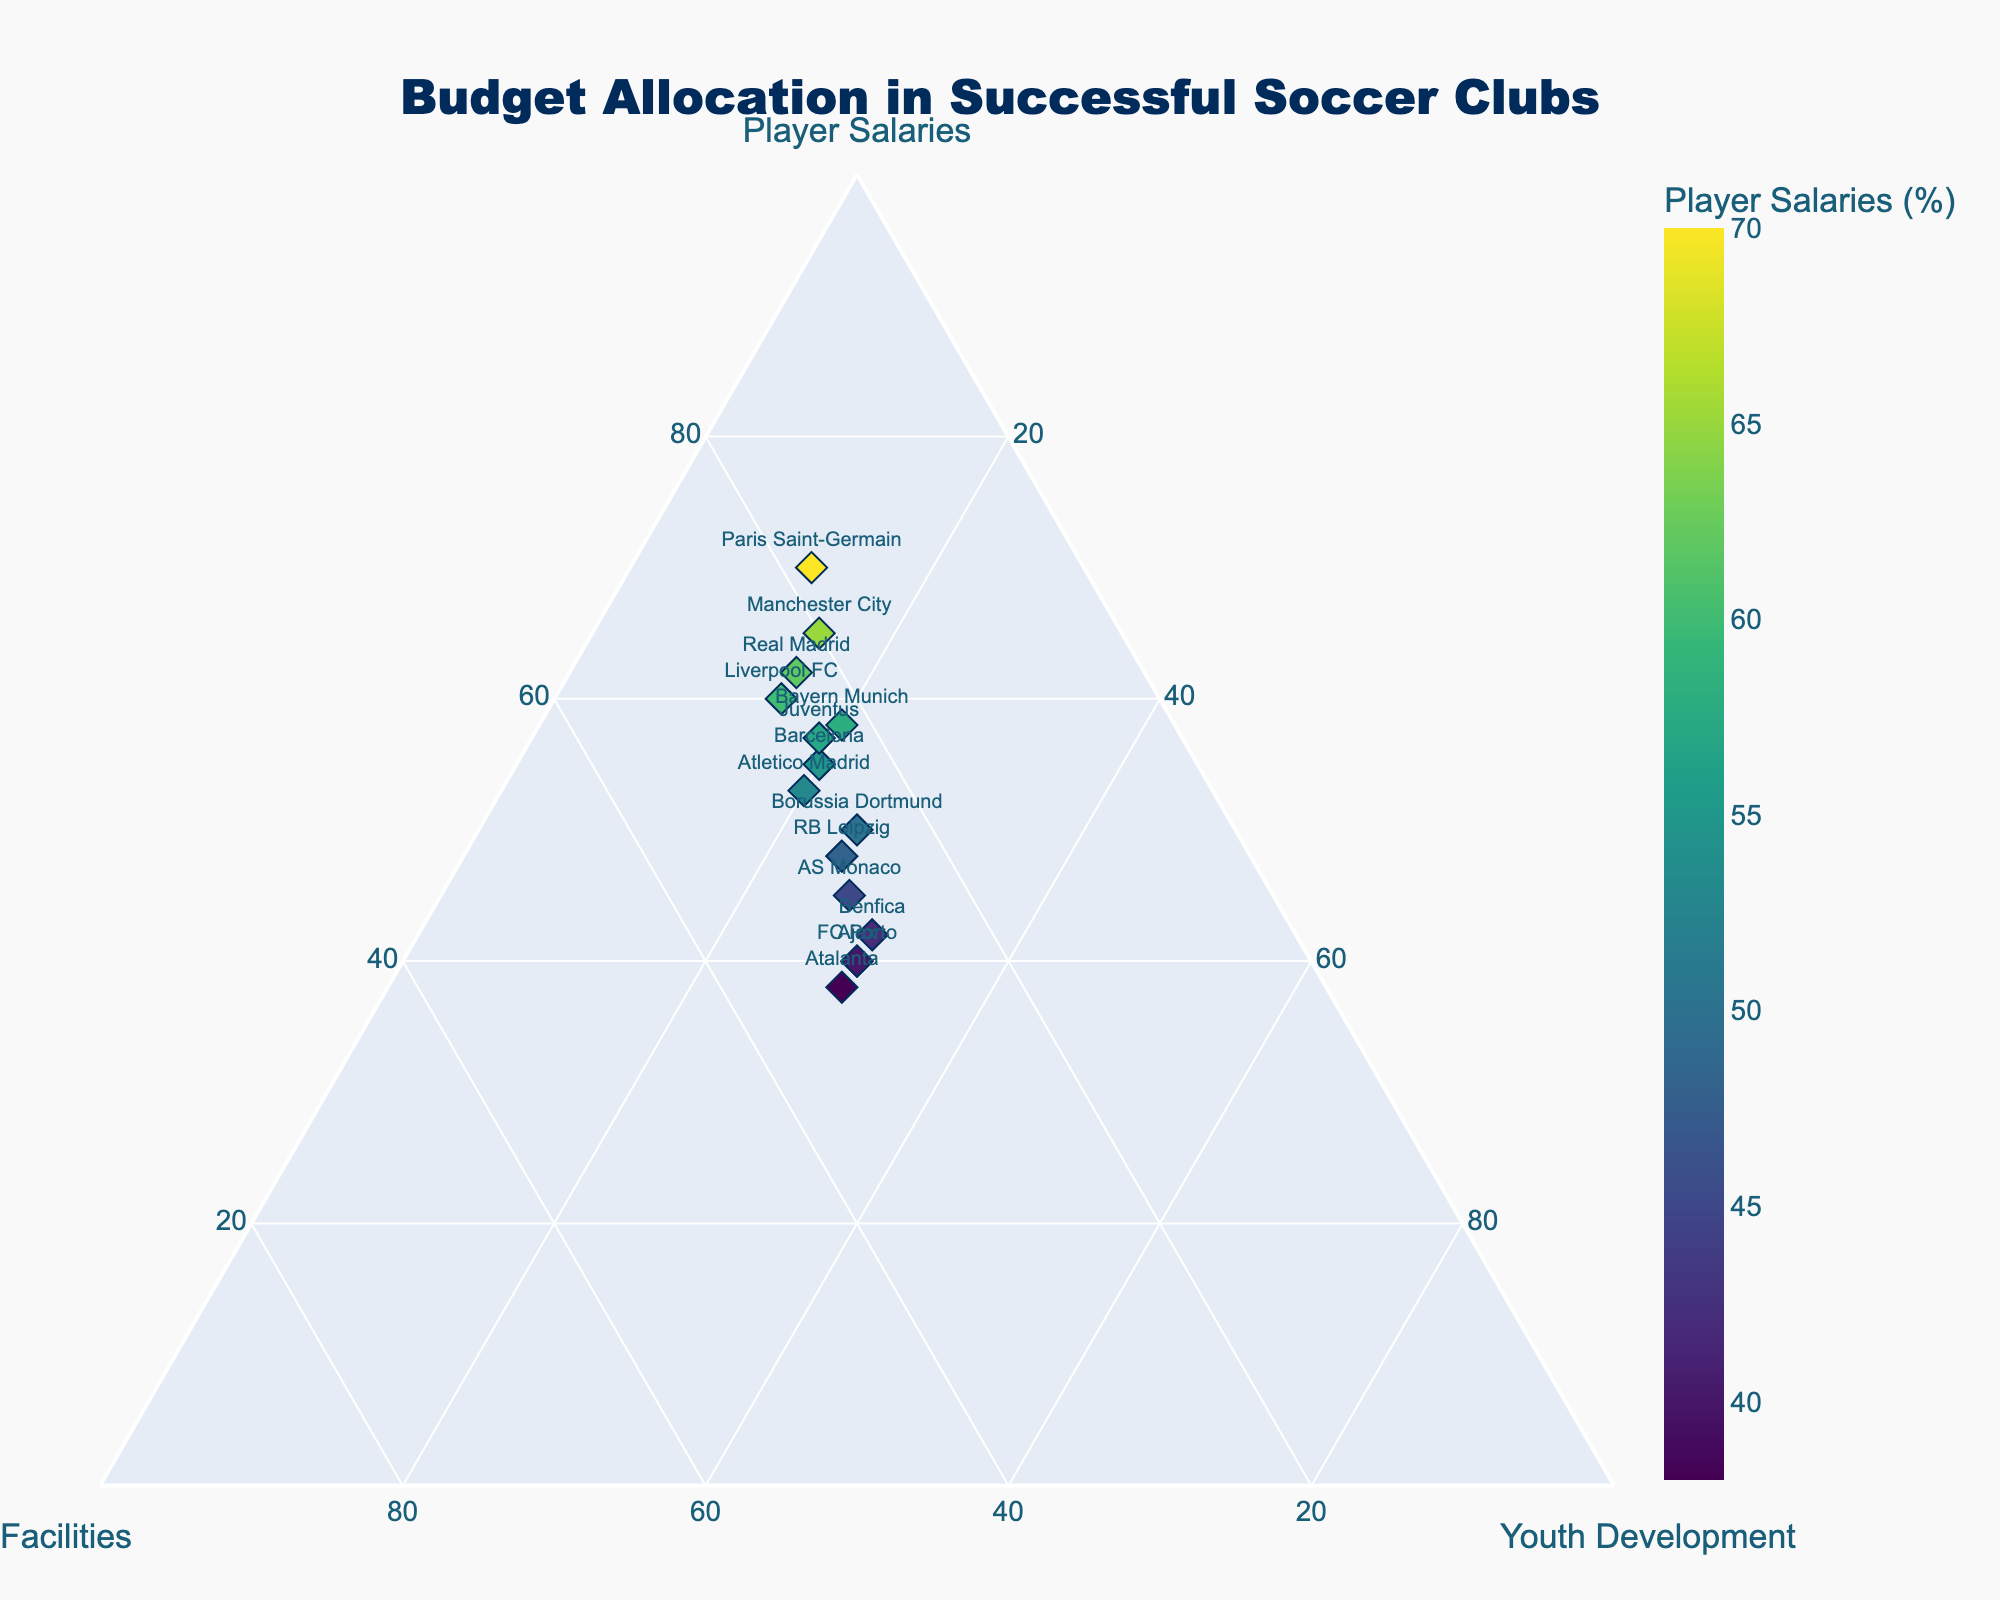What's the title of the plot? The title can be found at the top of the graph, often centered and in a larger font size. Just look at the top center of the plot.
Answer: Budget Allocation in Successful Soccer Clubs Which club allocates the highest percentage to Player Salaries? Find the point with the highest value on the Player Salaries axis. The color intensity of the marker also helps identify it. The club label adjacent to this point is the answer.
Answer: Paris Saint-Germain How many clubs allocate exactly 30% of their budget to Youth Development? Identify all points on the plot where the percentage for Youth Development is exactly 30%. Count the club labels next to these points.
Answer: 4 What is the percentage difference in Facilities allocation between Liverpool FC and AS Monaco? Subtract the percentage value for Facilities of AS Monaco from that of Liverpool FC. Liverpool FC allocates 25% and AS Monaco allocates 28%.
Answer: 3% Which club has the most balanced budget allocation among Player Salaries, Facilities, and Youth Development? Look for the point closest to the center of the ternary plot because it indicates balance among all three budget types. A club with roughly equal percentages for all three categories is balanced.
Answer: Ajax Do any clubs allocate a greater percentage of their budget to Youth Development than to Player Salaries? Identify clubs where the value for Youth Development is greater than the value for Player Salaries. Compare these two values for each club visually.
Answer: No Compare the allocation to Facilities between Juventus and RB Leipzig. Which club allocates a higher percentage? Identify the locations of the markers for Juventus and RB Leipzig, and read the Facilities values. Compare the percentages directly. Juventus allocates 24%, while RB Leipzig allocates 27%.
Answer: RB Leipzig Which club has the least allocation in Player Salaries, but the highest for Youth Development? Find the point with the lowest value on the Player Salaries axis and verify that it has the highest value on the Youth Development axis. Ajax and FC Porto both have low Player Salaries allocation and 30% for Youth Development but slightly compare all elements to confirm.
Answer: Ajax What is the average allocation to Facilities across all clubs? Sum the Facilities percentages for all clubs and divide by the number of clubs. (20 + 25 + 22 + 18 + 23 + 25 + 25 + 30 + 27 + 24 + 28 + 27 + 28 + 30 + 32) / 15 = 27%
Answer: 25.7% 